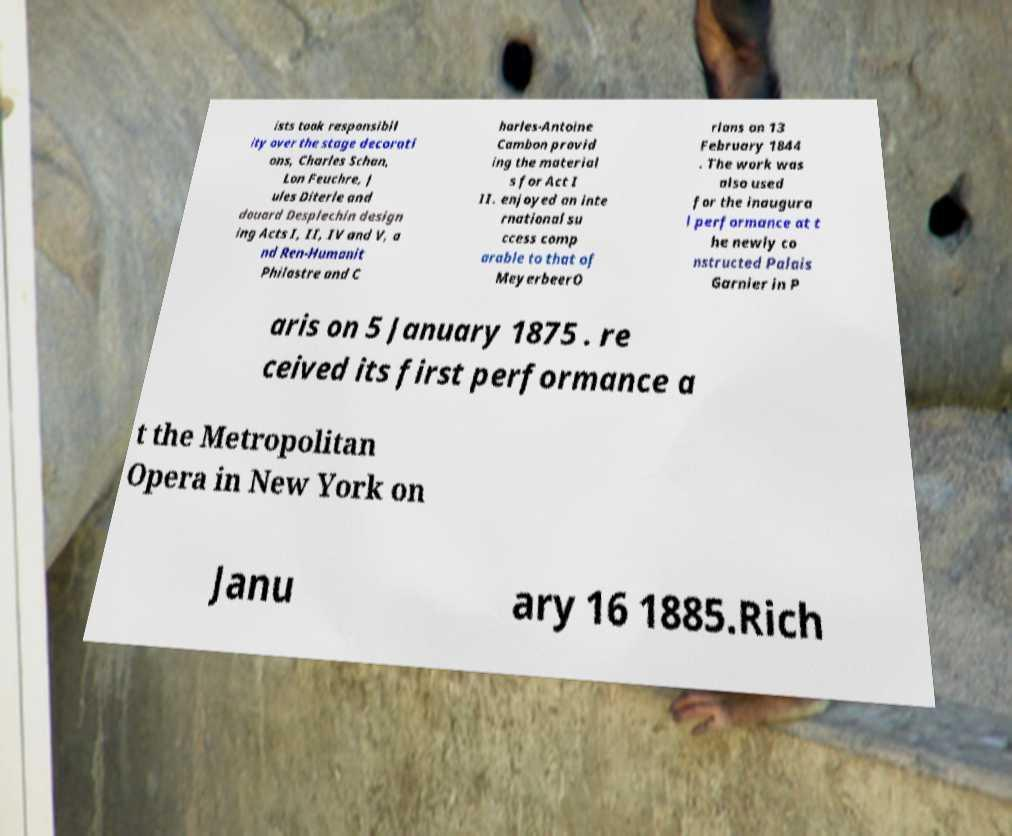I need the written content from this picture converted into text. Can you do that? ists took responsibil ity over the stage decorati ons, Charles Schan, Lon Feuchre, J ules Diterle and douard Desplechin design ing Acts I, II, IV and V, a nd Ren-Humanit Philastre and C harles-Antoine Cambon provid ing the material s for Act I II. enjoyed an inte rnational su ccess comp arable to that of MeyerbeerO rlans on 13 February 1844 . The work was also used for the inaugura l performance at t he newly co nstructed Palais Garnier in P aris on 5 January 1875 . re ceived its first performance a t the Metropolitan Opera in New York on Janu ary 16 1885.Rich 